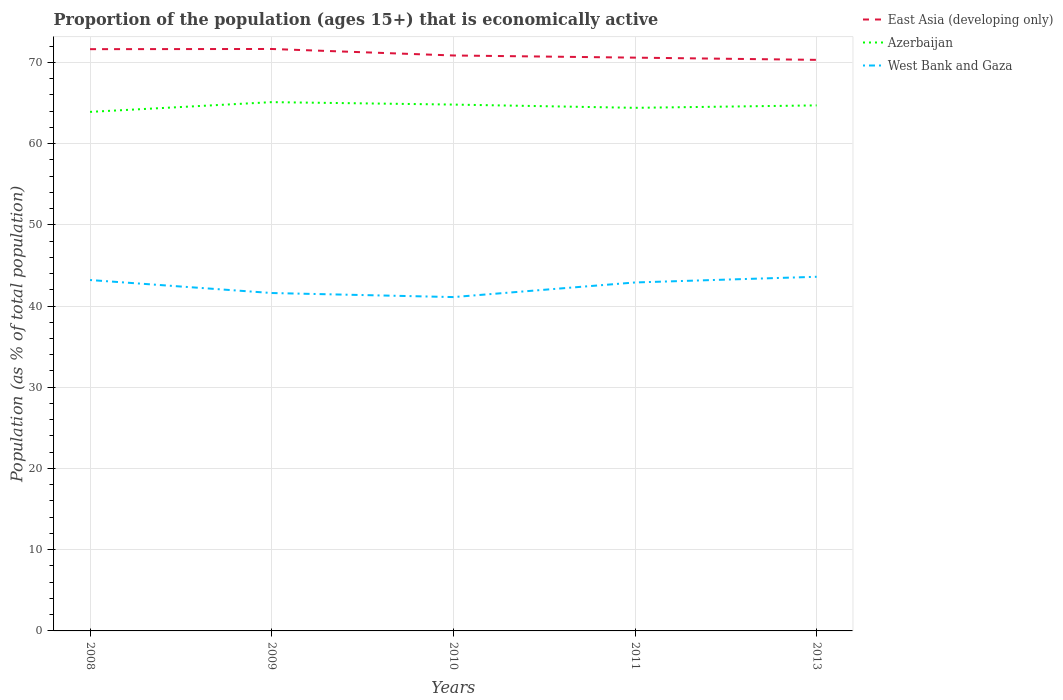Does the line corresponding to West Bank and Gaza intersect with the line corresponding to Azerbaijan?
Your response must be concise. No. Is the number of lines equal to the number of legend labels?
Your response must be concise. Yes. Across all years, what is the maximum proportion of the population that is economically active in West Bank and Gaza?
Keep it short and to the point. 41.1. In which year was the proportion of the population that is economically active in West Bank and Gaza maximum?
Keep it short and to the point. 2010. What is the total proportion of the population that is economically active in Azerbaijan in the graph?
Offer a very short reply. -1.2. What is the difference between the highest and the second highest proportion of the population that is economically active in Azerbaijan?
Provide a short and direct response. 1.2. What is the difference between the highest and the lowest proportion of the population that is economically active in West Bank and Gaza?
Keep it short and to the point. 3. Is the proportion of the population that is economically active in East Asia (developing only) strictly greater than the proportion of the population that is economically active in Azerbaijan over the years?
Offer a terse response. No. How many lines are there?
Your answer should be very brief. 3. What is the difference between two consecutive major ticks on the Y-axis?
Offer a terse response. 10. Where does the legend appear in the graph?
Keep it short and to the point. Top right. What is the title of the graph?
Make the answer very short. Proportion of the population (ages 15+) that is economically active. Does "Low & middle income" appear as one of the legend labels in the graph?
Provide a succinct answer. No. What is the label or title of the X-axis?
Your answer should be compact. Years. What is the label or title of the Y-axis?
Your response must be concise. Population (as % of total population). What is the Population (as % of total population) in East Asia (developing only) in 2008?
Offer a very short reply. 71.62. What is the Population (as % of total population) in Azerbaijan in 2008?
Offer a terse response. 63.9. What is the Population (as % of total population) in West Bank and Gaza in 2008?
Give a very brief answer. 43.2. What is the Population (as % of total population) in East Asia (developing only) in 2009?
Make the answer very short. 71.64. What is the Population (as % of total population) of Azerbaijan in 2009?
Give a very brief answer. 65.1. What is the Population (as % of total population) of West Bank and Gaza in 2009?
Provide a short and direct response. 41.6. What is the Population (as % of total population) in East Asia (developing only) in 2010?
Your response must be concise. 70.84. What is the Population (as % of total population) in Azerbaijan in 2010?
Give a very brief answer. 64.8. What is the Population (as % of total population) in West Bank and Gaza in 2010?
Provide a succinct answer. 41.1. What is the Population (as % of total population) in East Asia (developing only) in 2011?
Offer a terse response. 70.58. What is the Population (as % of total population) of Azerbaijan in 2011?
Offer a terse response. 64.4. What is the Population (as % of total population) in West Bank and Gaza in 2011?
Your answer should be very brief. 42.9. What is the Population (as % of total population) of East Asia (developing only) in 2013?
Offer a terse response. 70.31. What is the Population (as % of total population) of Azerbaijan in 2013?
Offer a terse response. 64.7. What is the Population (as % of total population) in West Bank and Gaza in 2013?
Keep it short and to the point. 43.6. Across all years, what is the maximum Population (as % of total population) of East Asia (developing only)?
Give a very brief answer. 71.64. Across all years, what is the maximum Population (as % of total population) of Azerbaijan?
Offer a very short reply. 65.1. Across all years, what is the maximum Population (as % of total population) in West Bank and Gaza?
Keep it short and to the point. 43.6. Across all years, what is the minimum Population (as % of total population) in East Asia (developing only)?
Keep it short and to the point. 70.31. Across all years, what is the minimum Population (as % of total population) of Azerbaijan?
Ensure brevity in your answer.  63.9. Across all years, what is the minimum Population (as % of total population) in West Bank and Gaza?
Provide a succinct answer. 41.1. What is the total Population (as % of total population) of East Asia (developing only) in the graph?
Offer a very short reply. 354.99. What is the total Population (as % of total population) of Azerbaijan in the graph?
Make the answer very short. 322.9. What is the total Population (as % of total population) in West Bank and Gaza in the graph?
Make the answer very short. 212.4. What is the difference between the Population (as % of total population) in East Asia (developing only) in 2008 and that in 2009?
Your answer should be very brief. -0.02. What is the difference between the Population (as % of total population) of East Asia (developing only) in 2008 and that in 2010?
Offer a very short reply. 0.78. What is the difference between the Population (as % of total population) of West Bank and Gaza in 2008 and that in 2010?
Give a very brief answer. 2.1. What is the difference between the Population (as % of total population) in East Asia (developing only) in 2008 and that in 2011?
Keep it short and to the point. 1.04. What is the difference between the Population (as % of total population) in Azerbaijan in 2008 and that in 2011?
Your answer should be very brief. -0.5. What is the difference between the Population (as % of total population) in East Asia (developing only) in 2008 and that in 2013?
Your answer should be compact. 1.32. What is the difference between the Population (as % of total population) in West Bank and Gaza in 2008 and that in 2013?
Provide a short and direct response. -0.4. What is the difference between the Population (as % of total population) of East Asia (developing only) in 2009 and that in 2010?
Your answer should be compact. 0.8. What is the difference between the Population (as % of total population) of East Asia (developing only) in 2009 and that in 2011?
Offer a terse response. 1.07. What is the difference between the Population (as % of total population) of Azerbaijan in 2009 and that in 2011?
Your response must be concise. 0.7. What is the difference between the Population (as % of total population) in West Bank and Gaza in 2009 and that in 2011?
Your answer should be very brief. -1.3. What is the difference between the Population (as % of total population) in East Asia (developing only) in 2009 and that in 2013?
Give a very brief answer. 1.34. What is the difference between the Population (as % of total population) in Azerbaijan in 2009 and that in 2013?
Your answer should be compact. 0.4. What is the difference between the Population (as % of total population) of West Bank and Gaza in 2009 and that in 2013?
Offer a terse response. -2. What is the difference between the Population (as % of total population) in East Asia (developing only) in 2010 and that in 2011?
Make the answer very short. 0.27. What is the difference between the Population (as % of total population) of Azerbaijan in 2010 and that in 2011?
Your answer should be very brief. 0.4. What is the difference between the Population (as % of total population) in West Bank and Gaza in 2010 and that in 2011?
Ensure brevity in your answer.  -1.8. What is the difference between the Population (as % of total population) of East Asia (developing only) in 2010 and that in 2013?
Provide a short and direct response. 0.54. What is the difference between the Population (as % of total population) in Azerbaijan in 2010 and that in 2013?
Give a very brief answer. 0.1. What is the difference between the Population (as % of total population) in East Asia (developing only) in 2011 and that in 2013?
Your answer should be very brief. 0.27. What is the difference between the Population (as % of total population) of East Asia (developing only) in 2008 and the Population (as % of total population) of Azerbaijan in 2009?
Offer a very short reply. 6.52. What is the difference between the Population (as % of total population) in East Asia (developing only) in 2008 and the Population (as % of total population) in West Bank and Gaza in 2009?
Keep it short and to the point. 30.02. What is the difference between the Population (as % of total population) in Azerbaijan in 2008 and the Population (as % of total population) in West Bank and Gaza in 2009?
Make the answer very short. 22.3. What is the difference between the Population (as % of total population) in East Asia (developing only) in 2008 and the Population (as % of total population) in Azerbaijan in 2010?
Offer a very short reply. 6.82. What is the difference between the Population (as % of total population) in East Asia (developing only) in 2008 and the Population (as % of total population) in West Bank and Gaza in 2010?
Offer a very short reply. 30.52. What is the difference between the Population (as % of total population) in Azerbaijan in 2008 and the Population (as % of total population) in West Bank and Gaza in 2010?
Offer a terse response. 22.8. What is the difference between the Population (as % of total population) in East Asia (developing only) in 2008 and the Population (as % of total population) in Azerbaijan in 2011?
Your answer should be compact. 7.22. What is the difference between the Population (as % of total population) of East Asia (developing only) in 2008 and the Population (as % of total population) of West Bank and Gaza in 2011?
Keep it short and to the point. 28.72. What is the difference between the Population (as % of total population) in East Asia (developing only) in 2008 and the Population (as % of total population) in Azerbaijan in 2013?
Give a very brief answer. 6.92. What is the difference between the Population (as % of total population) in East Asia (developing only) in 2008 and the Population (as % of total population) in West Bank and Gaza in 2013?
Make the answer very short. 28.02. What is the difference between the Population (as % of total population) in Azerbaijan in 2008 and the Population (as % of total population) in West Bank and Gaza in 2013?
Offer a very short reply. 20.3. What is the difference between the Population (as % of total population) of East Asia (developing only) in 2009 and the Population (as % of total population) of Azerbaijan in 2010?
Offer a very short reply. 6.84. What is the difference between the Population (as % of total population) in East Asia (developing only) in 2009 and the Population (as % of total population) in West Bank and Gaza in 2010?
Give a very brief answer. 30.54. What is the difference between the Population (as % of total population) in Azerbaijan in 2009 and the Population (as % of total population) in West Bank and Gaza in 2010?
Your answer should be very brief. 24. What is the difference between the Population (as % of total population) in East Asia (developing only) in 2009 and the Population (as % of total population) in Azerbaijan in 2011?
Offer a very short reply. 7.24. What is the difference between the Population (as % of total population) in East Asia (developing only) in 2009 and the Population (as % of total population) in West Bank and Gaza in 2011?
Give a very brief answer. 28.74. What is the difference between the Population (as % of total population) in Azerbaijan in 2009 and the Population (as % of total population) in West Bank and Gaza in 2011?
Make the answer very short. 22.2. What is the difference between the Population (as % of total population) of East Asia (developing only) in 2009 and the Population (as % of total population) of Azerbaijan in 2013?
Provide a succinct answer. 6.94. What is the difference between the Population (as % of total population) of East Asia (developing only) in 2009 and the Population (as % of total population) of West Bank and Gaza in 2013?
Provide a succinct answer. 28.04. What is the difference between the Population (as % of total population) in Azerbaijan in 2009 and the Population (as % of total population) in West Bank and Gaza in 2013?
Keep it short and to the point. 21.5. What is the difference between the Population (as % of total population) in East Asia (developing only) in 2010 and the Population (as % of total population) in Azerbaijan in 2011?
Provide a short and direct response. 6.44. What is the difference between the Population (as % of total population) in East Asia (developing only) in 2010 and the Population (as % of total population) in West Bank and Gaza in 2011?
Make the answer very short. 27.94. What is the difference between the Population (as % of total population) in Azerbaijan in 2010 and the Population (as % of total population) in West Bank and Gaza in 2011?
Provide a succinct answer. 21.9. What is the difference between the Population (as % of total population) of East Asia (developing only) in 2010 and the Population (as % of total population) of Azerbaijan in 2013?
Provide a short and direct response. 6.14. What is the difference between the Population (as % of total population) of East Asia (developing only) in 2010 and the Population (as % of total population) of West Bank and Gaza in 2013?
Provide a short and direct response. 27.24. What is the difference between the Population (as % of total population) in Azerbaijan in 2010 and the Population (as % of total population) in West Bank and Gaza in 2013?
Keep it short and to the point. 21.2. What is the difference between the Population (as % of total population) in East Asia (developing only) in 2011 and the Population (as % of total population) in Azerbaijan in 2013?
Your answer should be compact. 5.88. What is the difference between the Population (as % of total population) of East Asia (developing only) in 2011 and the Population (as % of total population) of West Bank and Gaza in 2013?
Give a very brief answer. 26.98. What is the difference between the Population (as % of total population) in Azerbaijan in 2011 and the Population (as % of total population) in West Bank and Gaza in 2013?
Give a very brief answer. 20.8. What is the average Population (as % of total population) of East Asia (developing only) per year?
Give a very brief answer. 71. What is the average Population (as % of total population) of Azerbaijan per year?
Provide a succinct answer. 64.58. What is the average Population (as % of total population) in West Bank and Gaza per year?
Your answer should be compact. 42.48. In the year 2008, what is the difference between the Population (as % of total population) in East Asia (developing only) and Population (as % of total population) in Azerbaijan?
Provide a short and direct response. 7.72. In the year 2008, what is the difference between the Population (as % of total population) of East Asia (developing only) and Population (as % of total population) of West Bank and Gaza?
Provide a short and direct response. 28.42. In the year 2008, what is the difference between the Population (as % of total population) of Azerbaijan and Population (as % of total population) of West Bank and Gaza?
Provide a succinct answer. 20.7. In the year 2009, what is the difference between the Population (as % of total population) in East Asia (developing only) and Population (as % of total population) in Azerbaijan?
Offer a terse response. 6.54. In the year 2009, what is the difference between the Population (as % of total population) in East Asia (developing only) and Population (as % of total population) in West Bank and Gaza?
Keep it short and to the point. 30.04. In the year 2010, what is the difference between the Population (as % of total population) in East Asia (developing only) and Population (as % of total population) in Azerbaijan?
Offer a terse response. 6.04. In the year 2010, what is the difference between the Population (as % of total population) of East Asia (developing only) and Population (as % of total population) of West Bank and Gaza?
Your answer should be compact. 29.74. In the year 2010, what is the difference between the Population (as % of total population) in Azerbaijan and Population (as % of total population) in West Bank and Gaza?
Your answer should be very brief. 23.7. In the year 2011, what is the difference between the Population (as % of total population) in East Asia (developing only) and Population (as % of total population) in Azerbaijan?
Your response must be concise. 6.18. In the year 2011, what is the difference between the Population (as % of total population) in East Asia (developing only) and Population (as % of total population) in West Bank and Gaza?
Make the answer very short. 27.68. In the year 2013, what is the difference between the Population (as % of total population) of East Asia (developing only) and Population (as % of total population) of Azerbaijan?
Your answer should be very brief. 5.61. In the year 2013, what is the difference between the Population (as % of total population) in East Asia (developing only) and Population (as % of total population) in West Bank and Gaza?
Make the answer very short. 26.71. In the year 2013, what is the difference between the Population (as % of total population) in Azerbaijan and Population (as % of total population) in West Bank and Gaza?
Provide a short and direct response. 21.1. What is the ratio of the Population (as % of total population) of Azerbaijan in 2008 to that in 2009?
Keep it short and to the point. 0.98. What is the ratio of the Population (as % of total population) in East Asia (developing only) in 2008 to that in 2010?
Give a very brief answer. 1.01. What is the ratio of the Population (as % of total population) in Azerbaijan in 2008 to that in 2010?
Keep it short and to the point. 0.99. What is the ratio of the Population (as % of total population) of West Bank and Gaza in 2008 to that in 2010?
Your answer should be compact. 1.05. What is the ratio of the Population (as % of total population) of East Asia (developing only) in 2008 to that in 2011?
Offer a very short reply. 1.01. What is the ratio of the Population (as % of total population) in Azerbaijan in 2008 to that in 2011?
Offer a very short reply. 0.99. What is the ratio of the Population (as % of total population) in West Bank and Gaza in 2008 to that in 2011?
Provide a short and direct response. 1.01. What is the ratio of the Population (as % of total population) in East Asia (developing only) in 2008 to that in 2013?
Provide a short and direct response. 1.02. What is the ratio of the Population (as % of total population) of Azerbaijan in 2008 to that in 2013?
Provide a succinct answer. 0.99. What is the ratio of the Population (as % of total population) in West Bank and Gaza in 2008 to that in 2013?
Provide a succinct answer. 0.99. What is the ratio of the Population (as % of total population) in East Asia (developing only) in 2009 to that in 2010?
Ensure brevity in your answer.  1.01. What is the ratio of the Population (as % of total population) of Azerbaijan in 2009 to that in 2010?
Offer a very short reply. 1. What is the ratio of the Population (as % of total population) in West Bank and Gaza in 2009 to that in 2010?
Provide a succinct answer. 1.01. What is the ratio of the Population (as % of total population) in East Asia (developing only) in 2009 to that in 2011?
Your answer should be compact. 1.02. What is the ratio of the Population (as % of total population) in Azerbaijan in 2009 to that in 2011?
Your answer should be very brief. 1.01. What is the ratio of the Population (as % of total population) of West Bank and Gaza in 2009 to that in 2011?
Ensure brevity in your answer.  0.97. What is the ratio of the Population (as % of total population) in East Asia (developing only) in 2009 to that in 2013?
Your answer should be very brief. 1.02. What is the ratio of the Population (as % of total population) in West Bank and Gaza in 2009 to that in 2013?
Offer a very short reply. 0.95. What is the ratio of the Population (as % of total population) in East Asia (developing only) in 2010 to that in 2011?
Make the answer very short. 1. What is the ratio of the Population (as % of total population) of Azerbaijan in 2010 to that in 2011?
Make the answer very short. 1.01. What is the ratio of the Population (as % of total population) in West Bank and Gaza in 2010 to that in 2011?
Offer a very short reply. 0.96. What is the ratio of the Population (as % of total population) of East Asia (developing only) in 2010 to that in 2013?
Your response must be concise. 1.01. What is the ratio of the Population (as % of total population) of West Bank and Gaza in 2010 to that in 2013?
Ensure brevity in your answer.  0.94. What is the ratio of the Population (as % of total population) in East Asia (developing only) in 2011 to that in 2013?
Provide a succinct answer. 1. What is the ratio of the Population (as % of total population) of Azerbaijan in 2011 to that in 2013?
Make the answer very short. 1. What is the ratio of the Population (as % of total population) of West Bank and Gaza in 2011 to that in 2013?
Keep it short and to the point. 0.98. What is the difference between the highest and the second highest Population (as % of total population) in East Asia (developing only)?
Your response must be concise. 0.02. What is the difference between the highest and the second highest Population (as % of total population) of Azerbaijan?
Provide a short and direct response. 0.3. What is the difference between the highest and the lowest Population (as % of total population) of East Asia (developing only)?
Ensure brevity in your answer.  1.34. What is the difference between the highest and the lowest Population (as % of total population) of West Bank and Gaza?
Offer a very short reply. 2.5. 